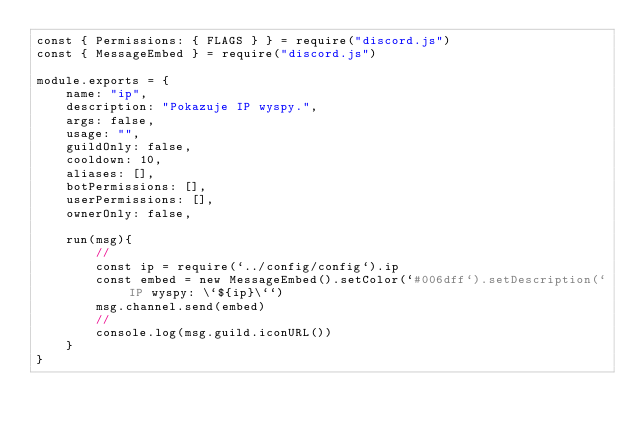Convert code to text. <code><loc_0><loc_0><loc_500><loc_500><_JavaScript_>const { Permissions: { FLAGS } } = require("discord.js")
const { MessageEmbed } = require("discord.js")

module.exports = {
    name: "ip",
    description: "Pokazuje IP wyspy.",
    args: false,
    usage: "",
    guildOnly: false,
    cooldown: 10,
    aliases: [],
    botPermissions: [],
    userPermissions: [],
    ownerOnly: false,

    run(msg){
        //
        const ip = require(`../config/config`).ip
        const embed = new MessageEmbed().setColor(`#006dff`).setDescription(`IP wyspy: \`${ip}\``)
        msg.channel.send(embed)
        //
        console.log(msg.guild.iconURL())
    }
}</code> 